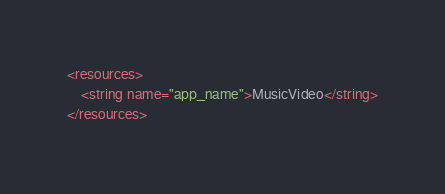Convert code to text. <code><loc_0><loc_0><loc_500><loc_500><_XML_><resources>
    <string name="app_name">MusicVideo</string>
</resources>
</code> 